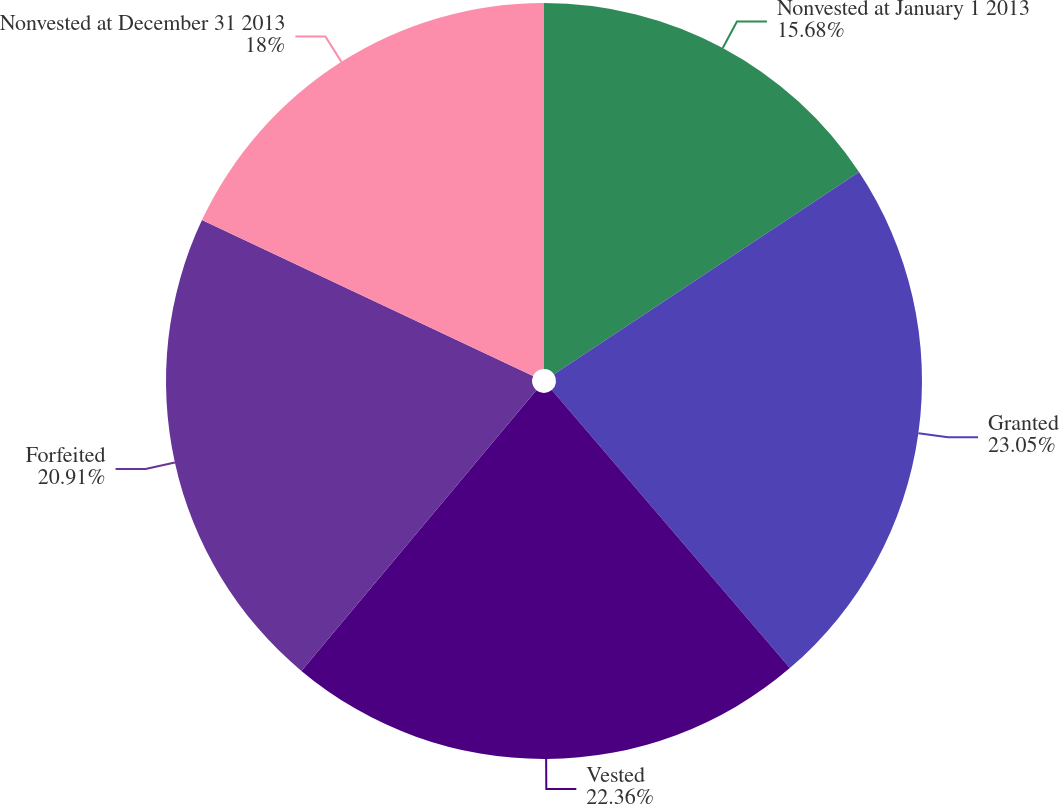Convert chart. <chart><loc_0><loc_0><loc_500><loc_500><pie_chart><fcel>Nonvested at January 1 2013<fcel>Granted<fcel>Vested<fcel>Forfeited<fcel>Nonvested at December 31 2013<nl><fcel>15.68%<fcel>23.05%<fcel>22.36%<fcel>20.91%<fcel>18.0%<nl></chart> 